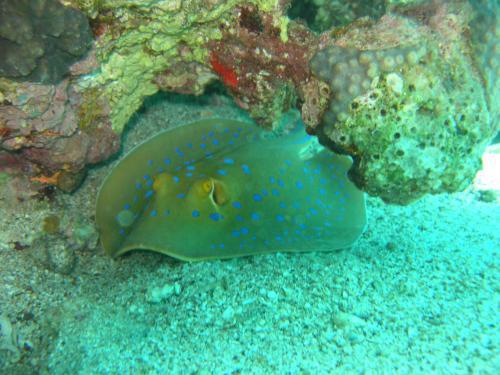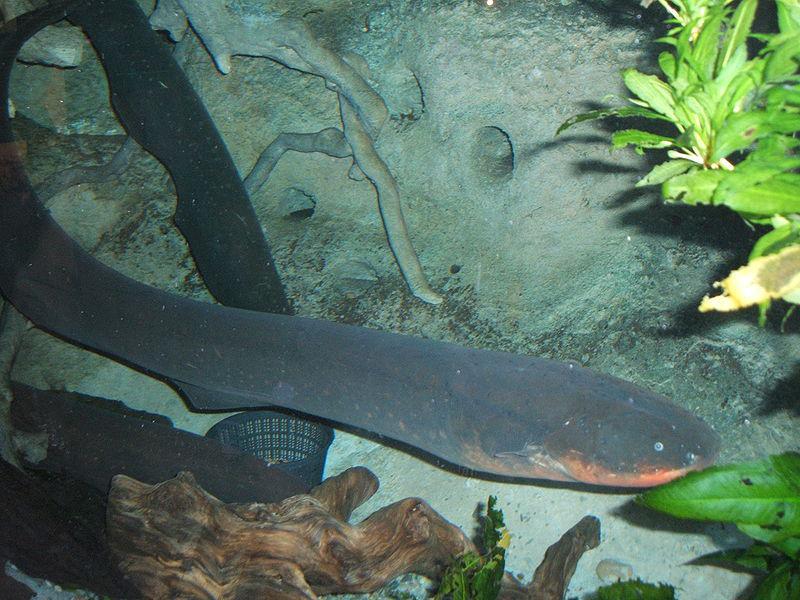The first image is the image on the left, the second image is the image on the right. Considering the images on both sides, is "At least one image contains a sea creature that is not a stingray." valid? Answer yes or no. Yes. 